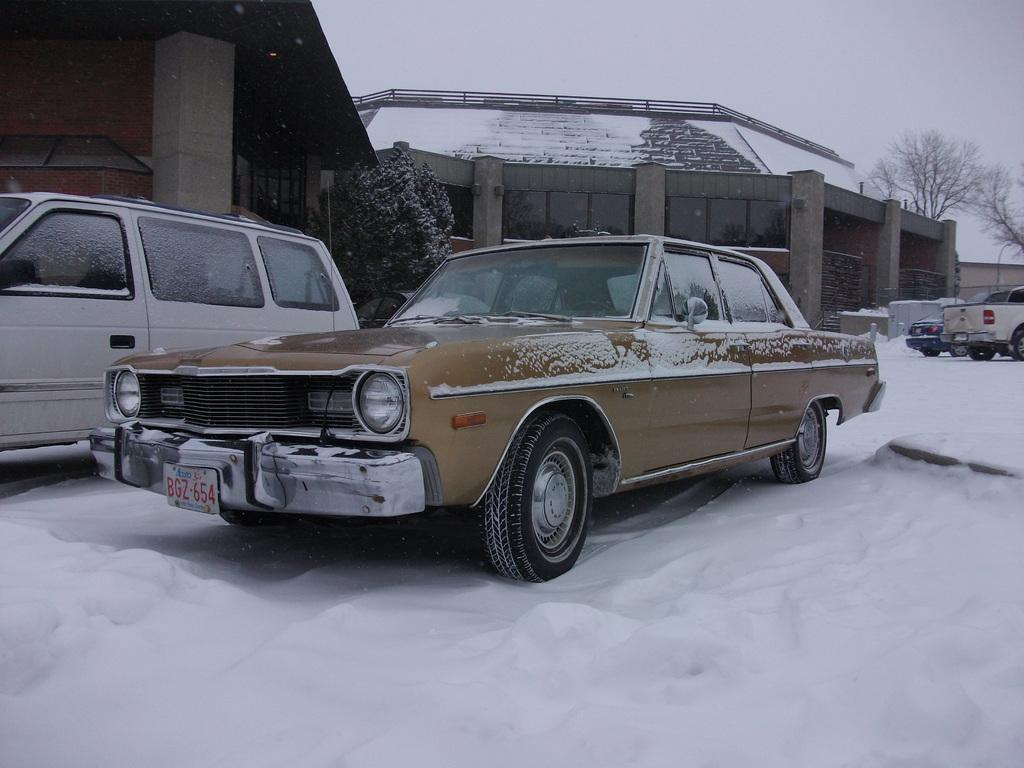What type of vehicles can be seen in the image? There are cars on the snow in the image. What is covering the land in the image? There is snow on the land in the image. What animals are present in the image? There are horses in the image. What type of vegetation can be seen in the image? There are trees in the image. What is visible in the background of the image? The sky is visible in the background of the image. Can you tell me how many fish are swimming in the snow in the image? There are no fish present in the image; it features cars on the snow, snow on the land, horses, trees, and a visible sky in the background. 